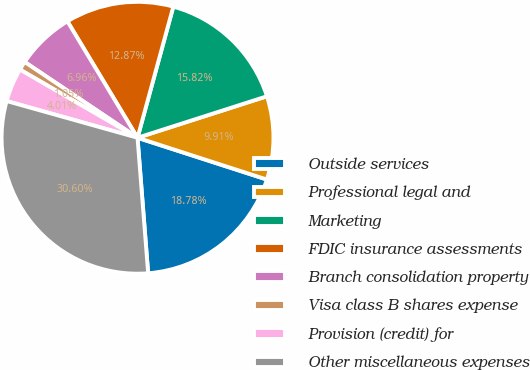Convert chart. <chart><loc_0><loc_0><loc_500><loc_500><pie_chart><fcel>Outside services<fcel>Professional legal and<fcel>Marketing<fcel>FDIC insurance assessments<fcel>Branch consolidation property<fcel>Visa class B shares expense<fcel>Provision (credit) for<fcel>Other miscellaneous expenses<nl><fcel>18.78%<fcel>9.91%<fcel>15.82%<fcel>12.87%<fcel>6.96%<fcel>1.05%<fcel>4.01%<fcel>30.6%<nl></chart> 